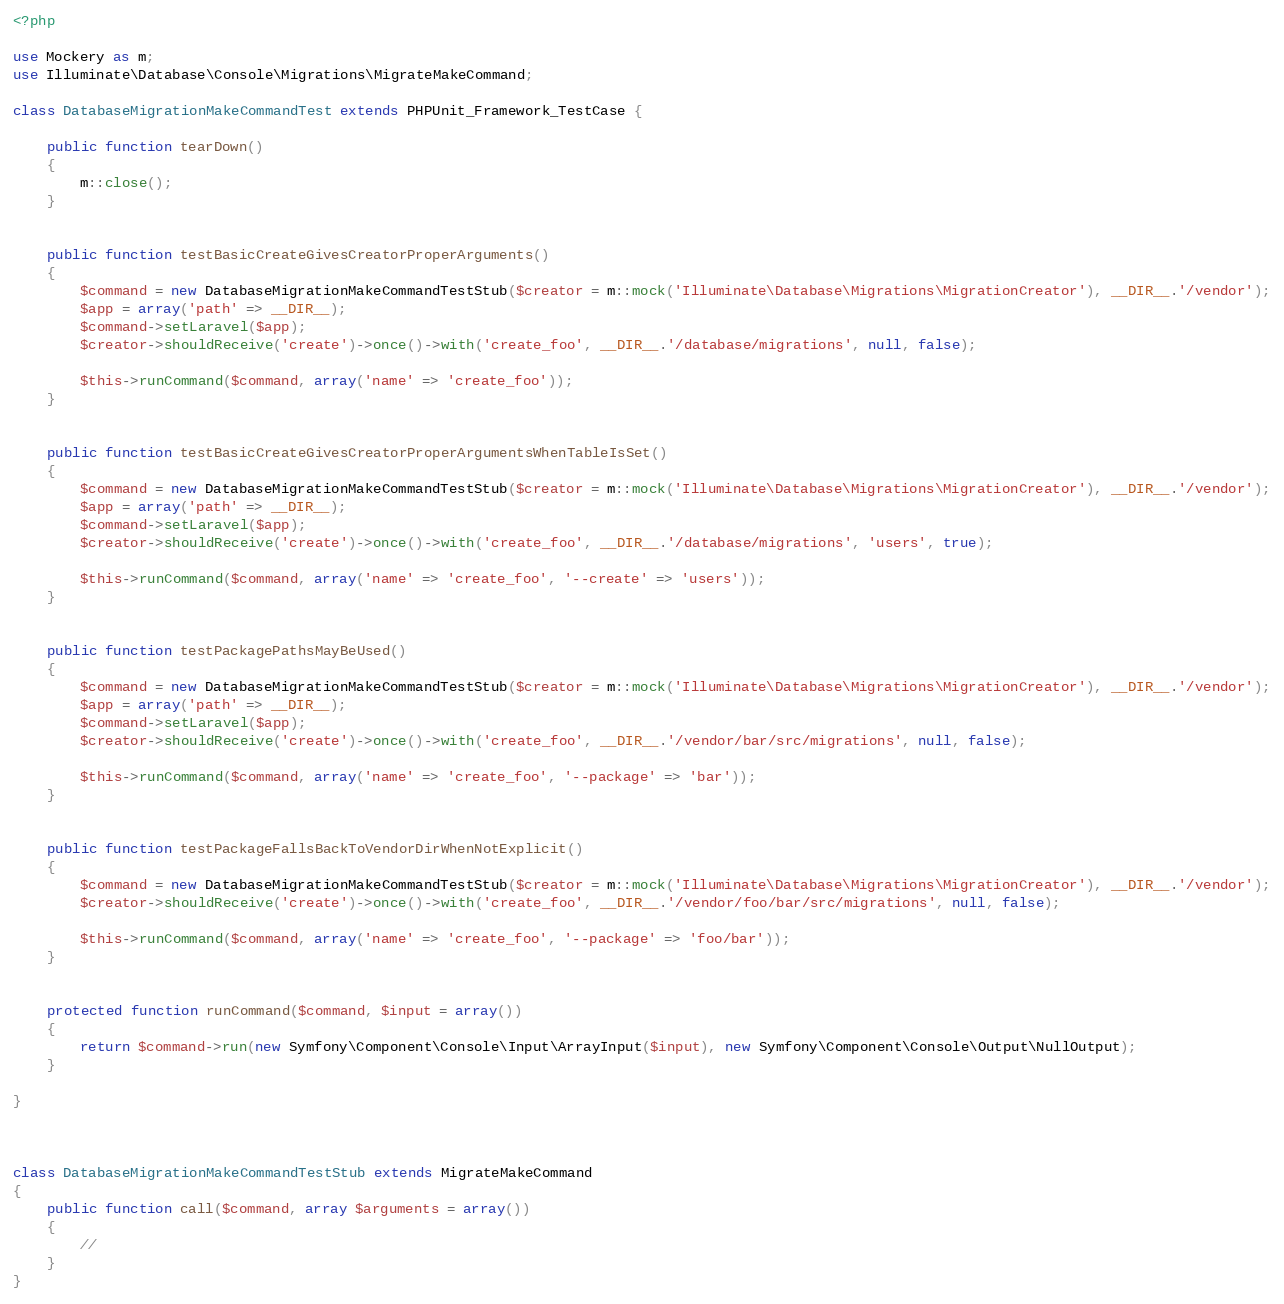<code> <loc_0><loc_0><loc_500><loc_500><_PHP_><?php

use Mockery as m;
use Illuminate\Database\Console\Migrations\MigrateMakeCommand;

class DatabaseMigrationMakeCommandTest extends PHPUnit_Framework_TestCase {

	public function tearDown()
	{
		m::close();
	}


	public function testBasicCreateGivesCreatorProperArguments()
	{
		$command = new DatabaseMigrationMakeCommandTestStub($creator = m::mock('Illuminate\Database\Migrations\MigrationCreator'), __DIR__.'/vendor');
		$app = array('path' => __DIR__);
		$command->setLaravel($app);
		$creator->shouldReceive('create')->once()->with('create_foo', __DIR__.'/database/migrations', null, false);

		$this->runCommand($command, array('name' => 'create_foo'));
	}


	public function testBasicCreateGivesCreatorProperArgumentsWhenTableIsSet()
	{
		$command = new DatabaseMigrationMakeCommandTestStub($creator = m::mock('Illuminate\Database\Migrations\MigrationCreator'), __DIR__.'/vendor');
		$app = array('path' => __DIR__);
		$command->setLaravel($app);
		$creator->shouldReceive('create')->once()->with('create_foo', __DIR__.'/database/migrations', 'users', true);

		$this->runCommand($command, array('name' => 'create_foo', '--create' => 'users'));
	}


	public function testPackagePathsMayBeUsed()
	{
		$command = new DatabaseMigrationMakeCommandTestStub($creator = m::mock('Illuminate\Database\Migrations\MigrationCreator'), __DIR__.'/vendor');
		$app = array('path' => __DIR__);
		$command->setLaravel($app);
		$creator->shouldReceive('create')->once()->with('create_foo', __DIR__.'/vendor/bar/src/migrations', null, false);

		$this->runCommand($command, array('name' => 'create_foo', '--package' => 'bar'));
	}


	public function testPackageFallsBackToVendorDirWhenNotExplicit()
	{
		$command = new DatabaseMigrationMakeCommandTestStub($creator = m::mock('Illuminate\Database\Migrations\MigrationCreator'), __DIR__.'/vendor');
		$creator->shouldReceive('create')->once()->with('create_foo', __DIR__.'/vendor/foo/bar/src/migrations', null, false);

		$this->runCommand($command, array('name' => 'create_foo', '--package' => 'foo/bar'));
	}


	protected function runCommand($command, $input = array())
	{
		return $command->run(new Symfony\Component\Console\Input\ArrayInput($input), new Symfony\Component\Console\Output\NullOutput);
	}

}



class DatabaseMigrationMakeCommandTestStub extends MigrateMakeCommand
{
	public function call($command, array $arguments = array())
	{
		//
	}
}
</code> 